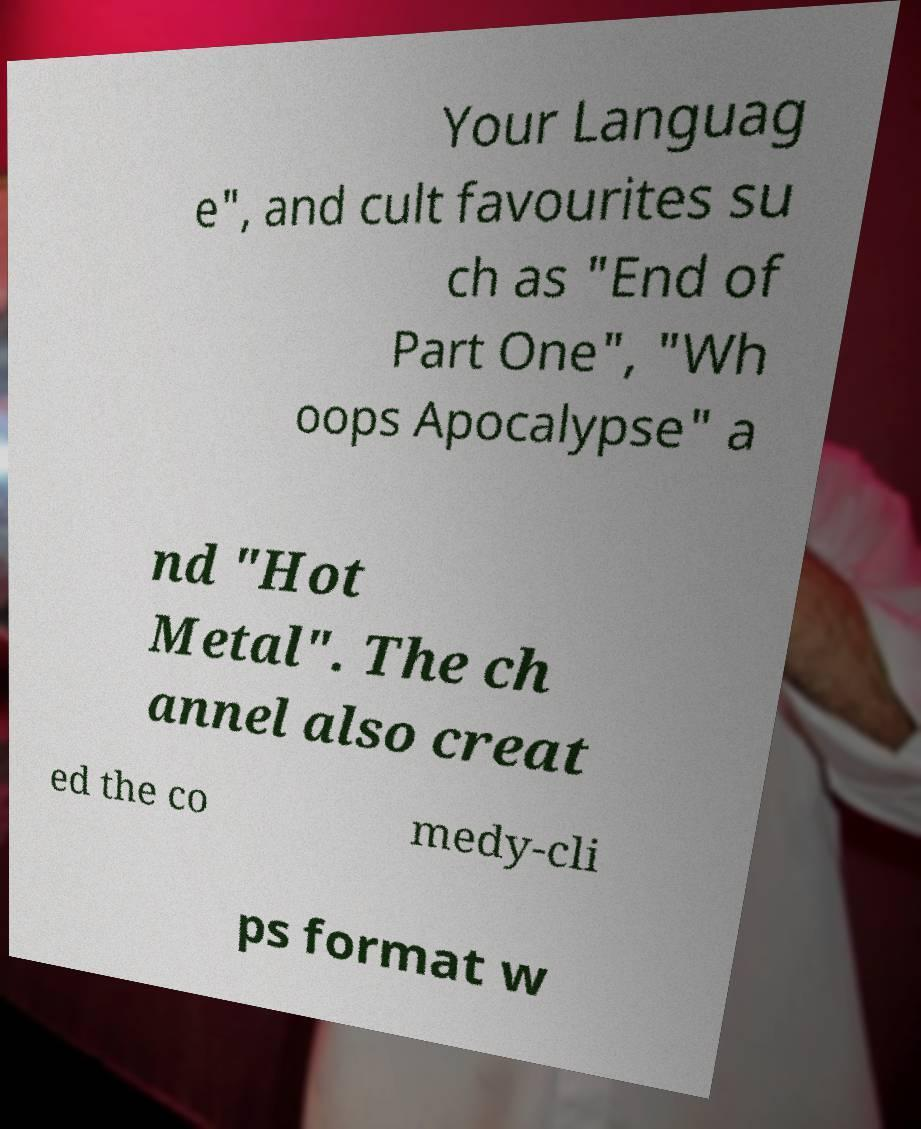Please identify and transcribe the text found in this image. Your Languag e", and cult favourites su ch as "End of Part One", "Wh oops Apocalypse" a nd "Hot Metal". The ch annel also creat ed the co medy-cli ps format w 